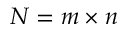Convert formula to latex. <formula><loc_0><loc_0><loc_500><loc_500>N = m \times n</formula> 